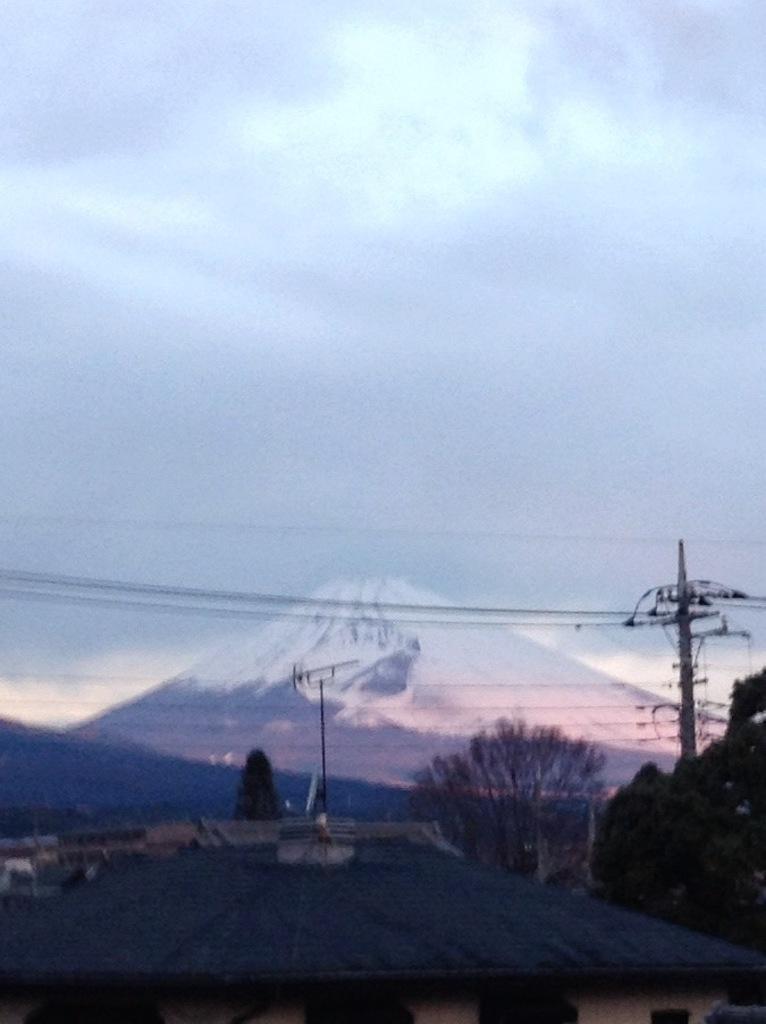Please provide a concise description of this image. In this image I see the poles and the wires and I see number of trees. In the background I see the mountain and the cloudy sky. 